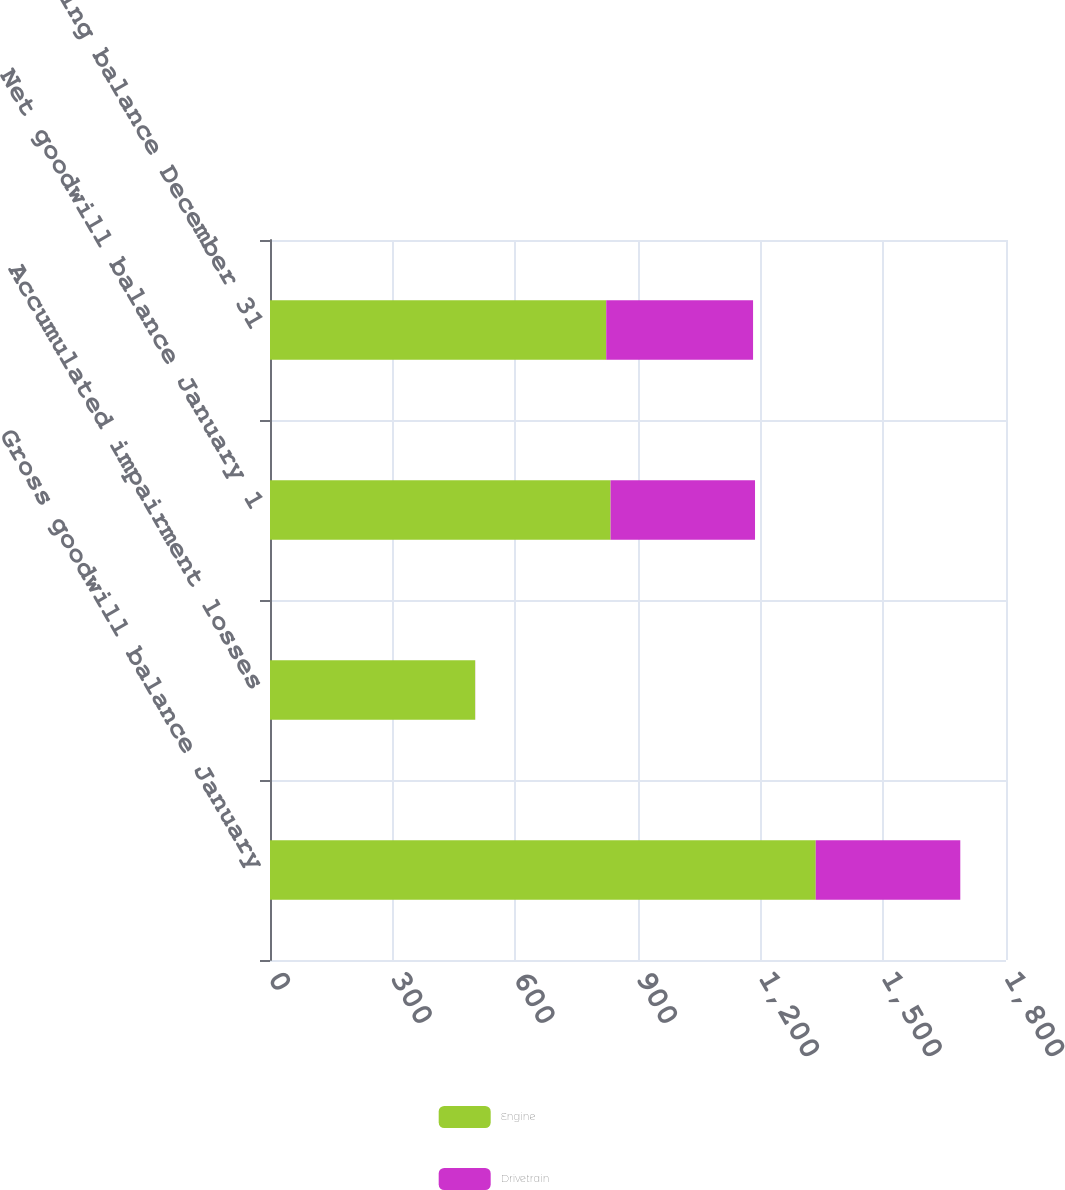Convert chart to OTSL. <chart><loc_0><loc_0><loc_500><loc_500><stacked_bar_chart><ecel><fcel>Gross goodwill balance January<fcel>Accumulated impairment losses<fcel>Net goodwill balance January 1<fcel>Ending balance December 31<nl><fcel>Engine<fcel>1334.7<fcel>501.8<fcel>832.9<fcel>822.3<nl><fcel>Drivetrain<fcel>353.5<fcel>0.2<fcel>353.3<fcel>359.1<nl></chart> 